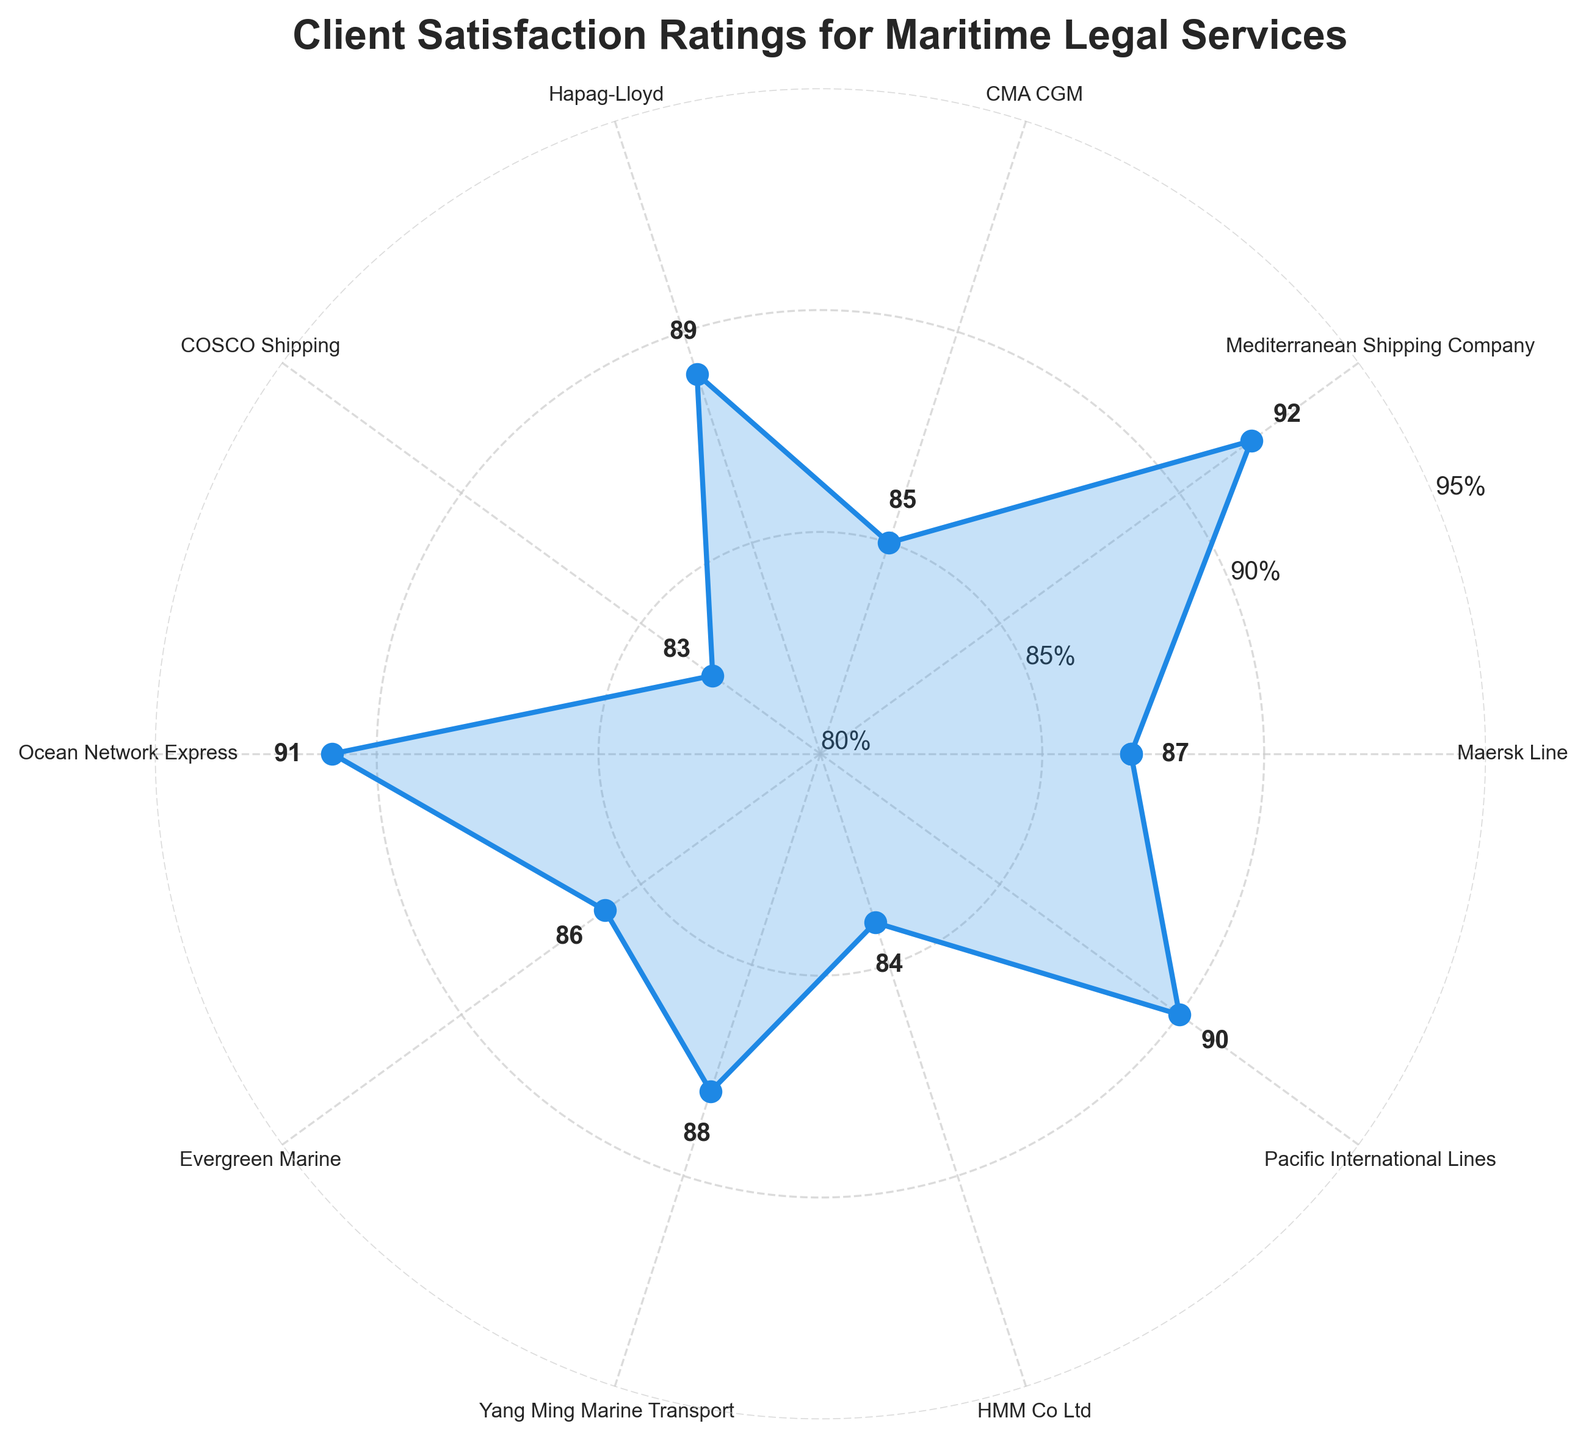What is the highest client satisfaction rating displayed on the chart? The chart shows ratings for several clients, and the highest rating is represented at the top part of the plot. By inspecting the chart, the highest rating can be identified as 92%.
Answer: 92% How many clients have a satisfaction rating above 90%? By examining the markers on the plot, identify which ones are above the 90% line. The clients with ratings above 90% are Mediterranean Shipping Company (92%), Ocean Network Express (91%), and Pacific International Lines (90%). This totals to 3 clients.
Answer: 3 What is the average client satisfaction rating based on the chart? The chart presents a mean value indicator at the center of the gauge. The value displayed in the center represents the average satisfaction rating. According to it, the average satisfaction rating is 88.5%.
Answer: 88.5% Which client has the lowest satisfaction rating and what is that rating? Observing the outer ring of the radial chart, which displays client names and their corresponding ratings, the client with the lowest rating can be found as COSCO Shipping with a rating of 83%.
Answer: COSCO Shipping, 83% How does the satisfaction rating of Hapag-Lloyd compare to that of CMA CGM? Hapag-Lloyd’s rating is 89% and CMA CGM’s rating is 85%. Hapag-Lloyd’s rating is higher.
Answer: Hapag-Lloyd’s rating is higher What percentage of clients have satisfaction ratings between 85% and 90%? Counting clients with ratings within the range specified, there are 6 clients: Maersk Line (87%), CMA CGM (85%), Hapag-Lloyd (89%), Ocean Network Express (91%), Evergreen Marine (86%), and Yang Ming Marine Transport (88%). Out of 10 clients in total, 6 are in this range, which is 60%.
Answer: 60% What visual indicator is used to represent the average satisfaction rating on the chart? The average satisfaction rating is indicated by a red needle on the gauge, pointing towards the average value. Additionally, the specific percentage is written in the center of the gauge.
Answer: Red needle and percentage text Which two clients have satisfaction ratings closest to each other? By checking the proximity of the markers along the chart's ring, Yang Ming Marine Transport (88%) and Hapag-Lloyd (89%) have the smallest difference of just 1%.
Answer: Yang Ming Marine Transport and Hapag-Lloyd What rating is displayed at the lowest tick mark on the y-axis? The radial chart has tick marks for the ratings. The lowest tick mark on the y-axis is labeled as 80%.
Answer: 80% What color is used to fill the area under the satisfaction ratings plot line? The filled area under the plot line correlating to the satisfaction ratings is shaded in a light blue color.
Answer: Light blue 